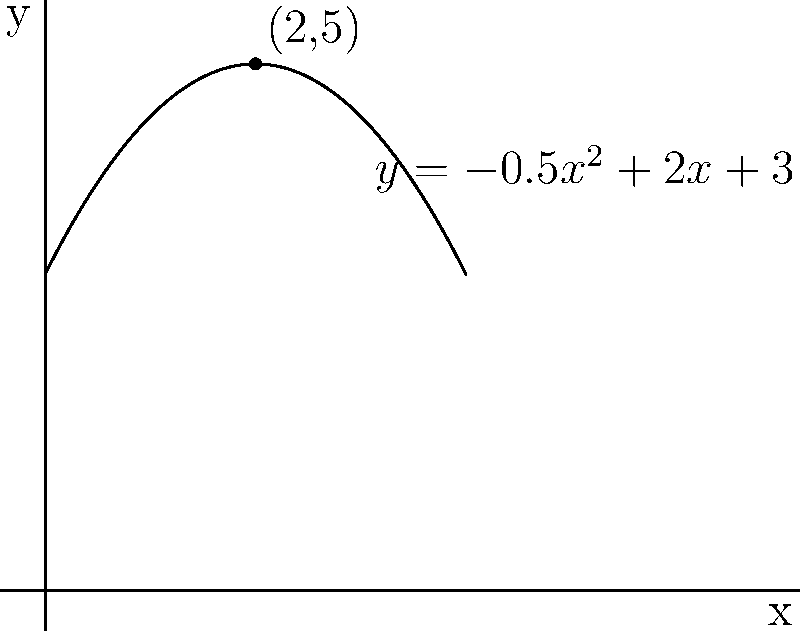During a ceremonial sword demonstration at the Royal Academy in 1650, a nobleman swings his sword in an arc that can be modeled by the equation $y = -0.5x^2 + 2x + 3$, where $x$ is the horizontal distance in meters and $y$ is the height in meters. What is the maximum height reached by the tip of the sword during this demonstration? To find the maximum height of the parabolic arc, we need to follow these steps:

1) The equation of the parabola is $y = -0.5x^2 + 2x + 3$

2) For a quadratic equation in the form $y = ax^2 + bx + c$, the x-coordinate of the vertex is given by $x = -\frac{b}{2a}$

3) In this case, $a = -0.5$, $b = 2$, and $c = 3$

4) Substituting these values:
   $x = -\frac{2}{2(-0.5)} = -\frac{2}{-1} = 2$

5) To find the y-coordinate (maximum height), we substitute $x = 2$ into the original equation:
   $y = -0.5(2)^2 + 2(2) + 3$
   $y = -0.5(4) + 4 + 3$
   $y = -2 + 4 + 3 = 5$

6) Therefore, the vertex of the parabola is at the point (2, 5)

The maximum height reached by the tip of the sword is 5 meters.
Answer: 5 meters 